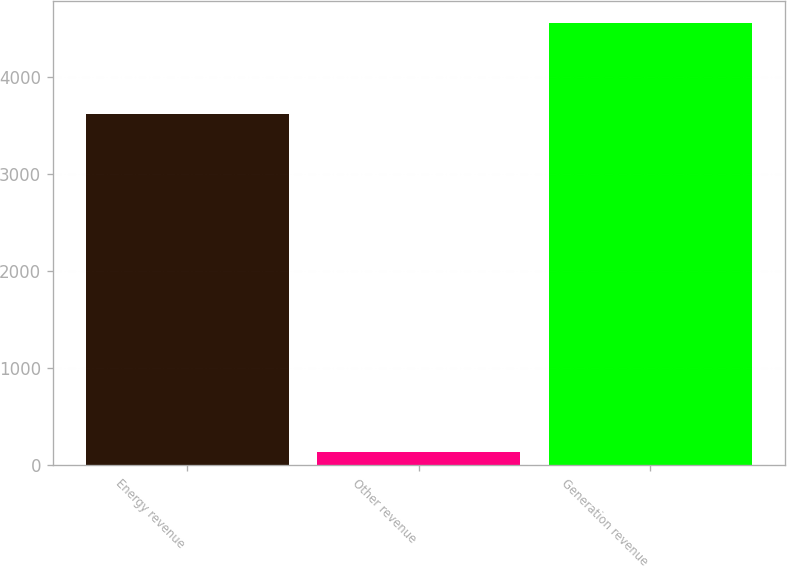Convert chart. <chart><loc_0><loc_0><loc_500><loc_500><bar_chart><fcel>Energy revenue<fcel>Other revenue<fcel>Generation revenue<nl><fcel>3626<fcel>134<fcel>4560<nl></chart> 